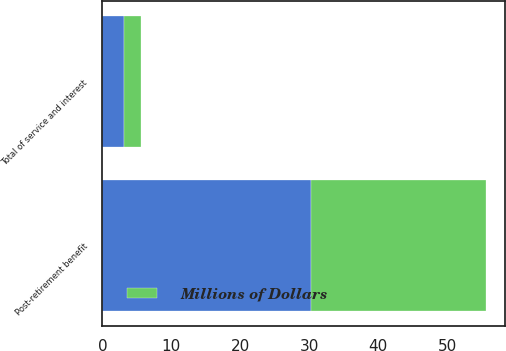<chart> <loc_0><loc_0><loc_500><loc_500><stacked_bar_chart><ecel><fcel>Post-retirement benefit<fcel>Total of service and interest<nl><fcel>nan<fcel>30.2<fcel>3.1<nl><fcel>Millions of Dollars<fcel>25.4<fcel>2.5<nl></chart> 